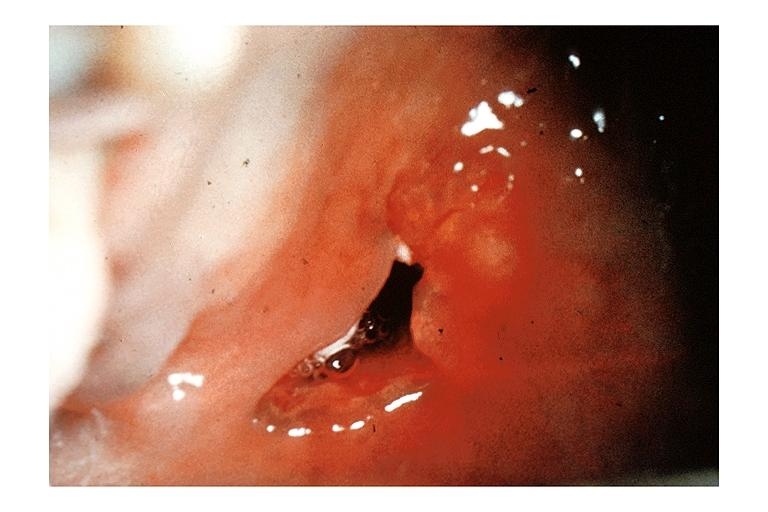does intraductal papillomatosis with apocrine metaplasia show mucoepidermoid carcinoma?
Answer the question using a single word or phrase. No 